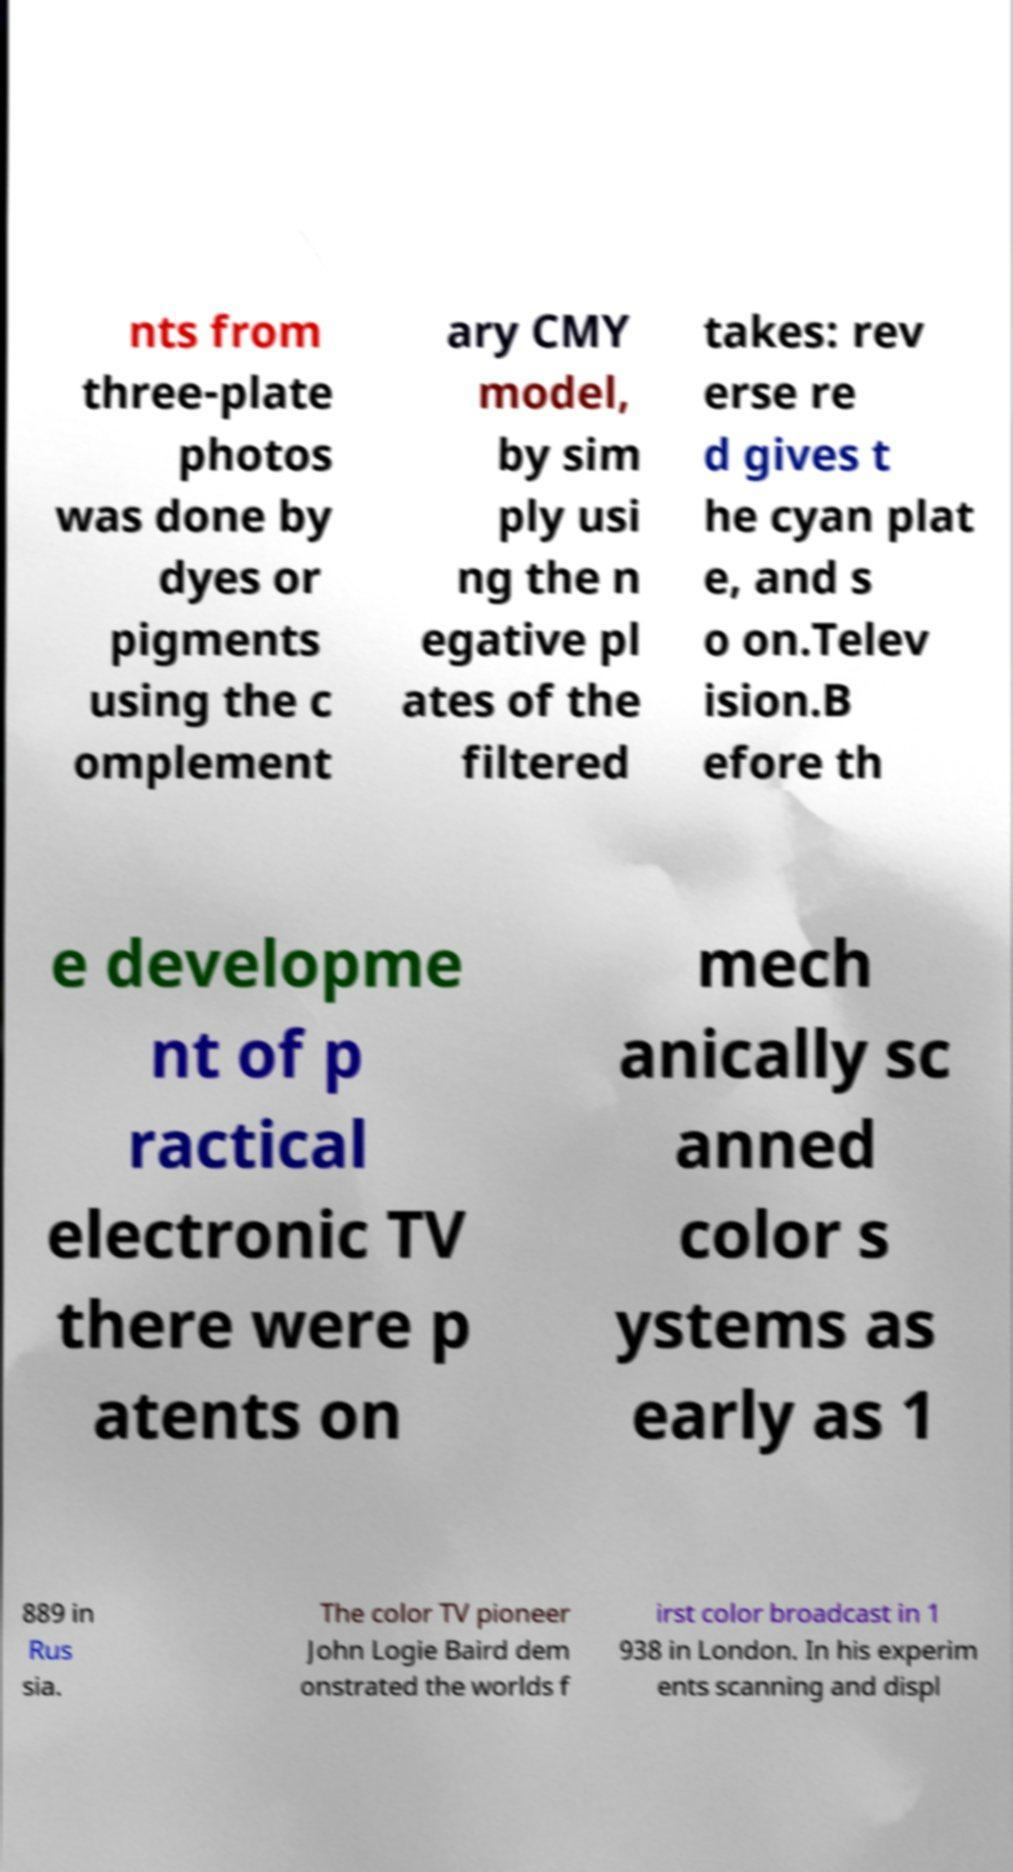What messages or text are displayed in this image? I need them in a readable, typed format. nts from three-plate photos was done by dyes or pigments using the c omplement ary CMY model, by sim ply usi ng the n egative pl ates of the filtered takes: rev erse re d gives t he cyan plat e, and s o on.Telev ision.B efore th e developme nt of p ractical electronic TV there were p atents on mech anically sc anned color s ystems as early as 1 889 in Rus sia. The color TV pioneer John Logie Baird dem onstrated the worlds f irst color broadcast in 1 938 in London. In his experim ents scanning and displ 